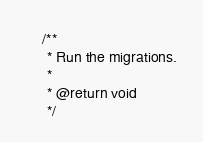Convert code to text. <code><loc_0><loc_0><loc_500><loc_500><_PHP_>    /**
     * Run the migrations.
     *
     * @return void
     */</code> 